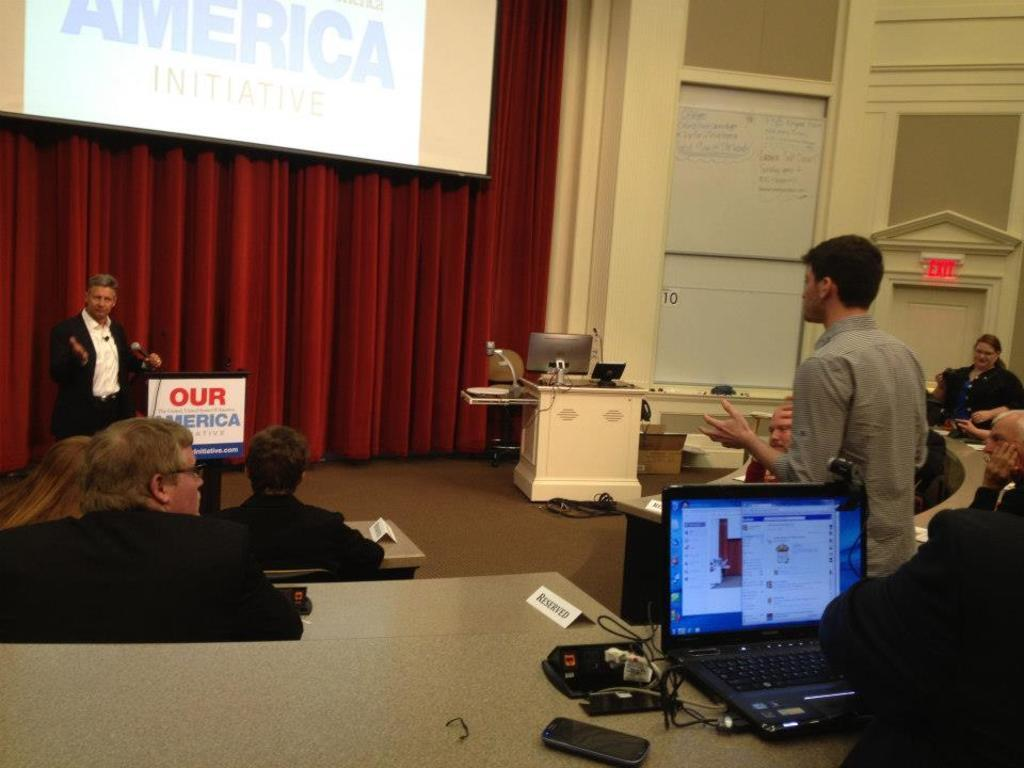<image>
Give a short and clear explanation of the subsequent image. Man giving a presentation while talking to a man standing in front of an Our America sign. 